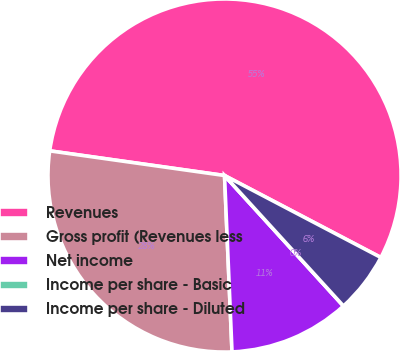<chart> <loc_0><loc_0><loc_500><loc_500><pie_chart><fcel>Revenues<fcel>Gross profit (Revenues less<fcel>Net income<fcel>Income per share - Basic<fcel>Income per share - Diluted<nl><fcel>55.46%<fcel>27.91%<fcel>11.09%<fcel>0.0%<fcel>5.55%<nl></chart> 